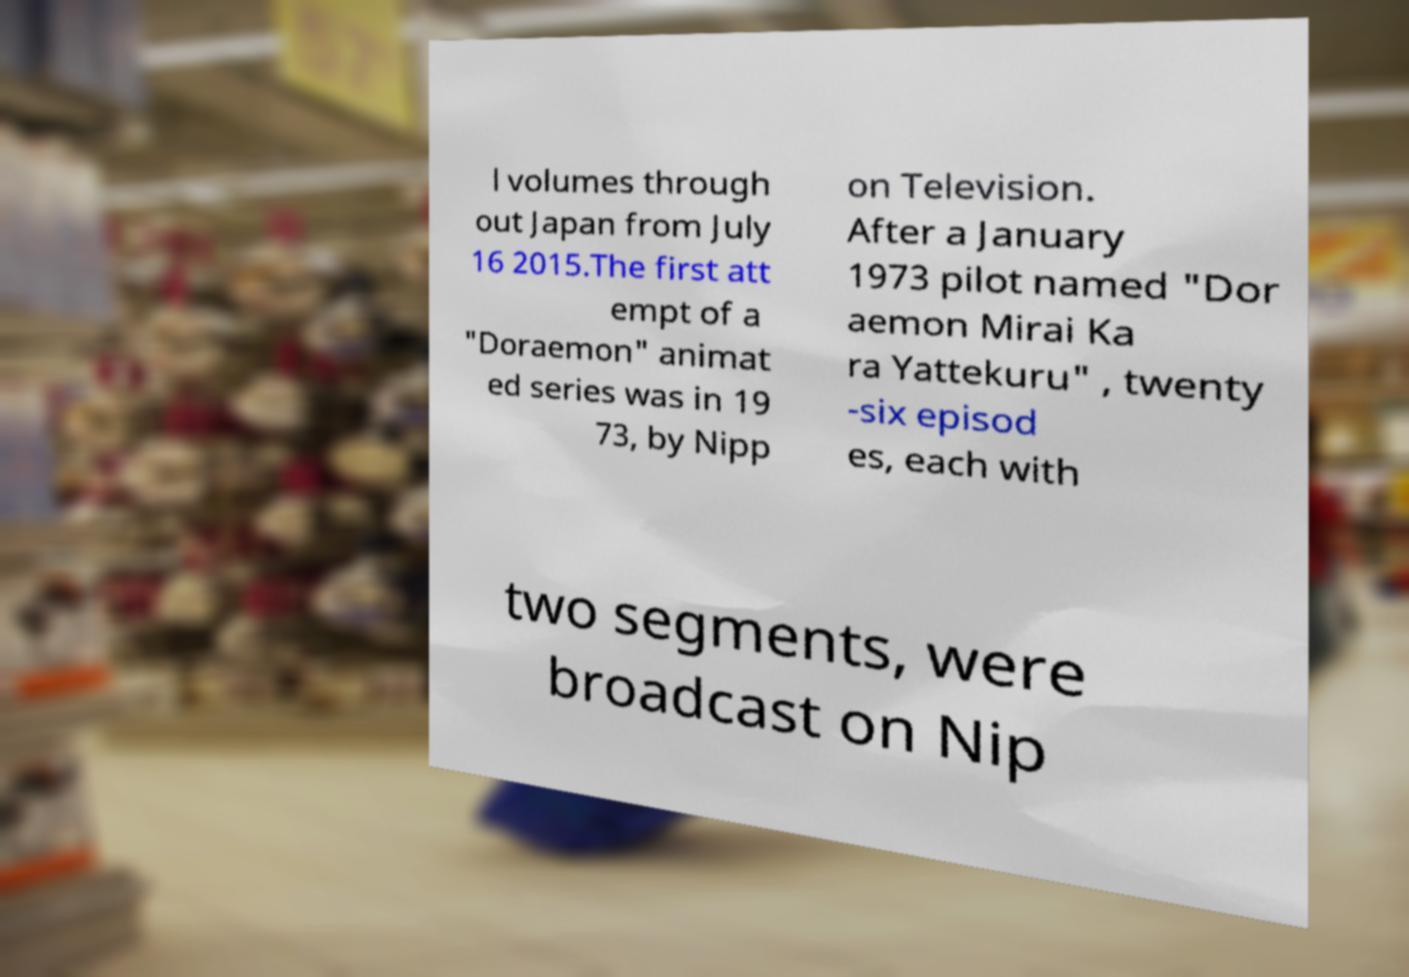There's text embedded in this image that I need extracted. Can you transcribe it verbatim? l volumes through out Japan from July 16 2015.The first att empt of a "Doraemon" animat ed series was in 19 73, by Nipp on Television. After a January 1973 pilot named "Dor aemon Mirai Ka ra Yattekuru" , twenty -six episod es, each with two segments, were broadcast on Nip 